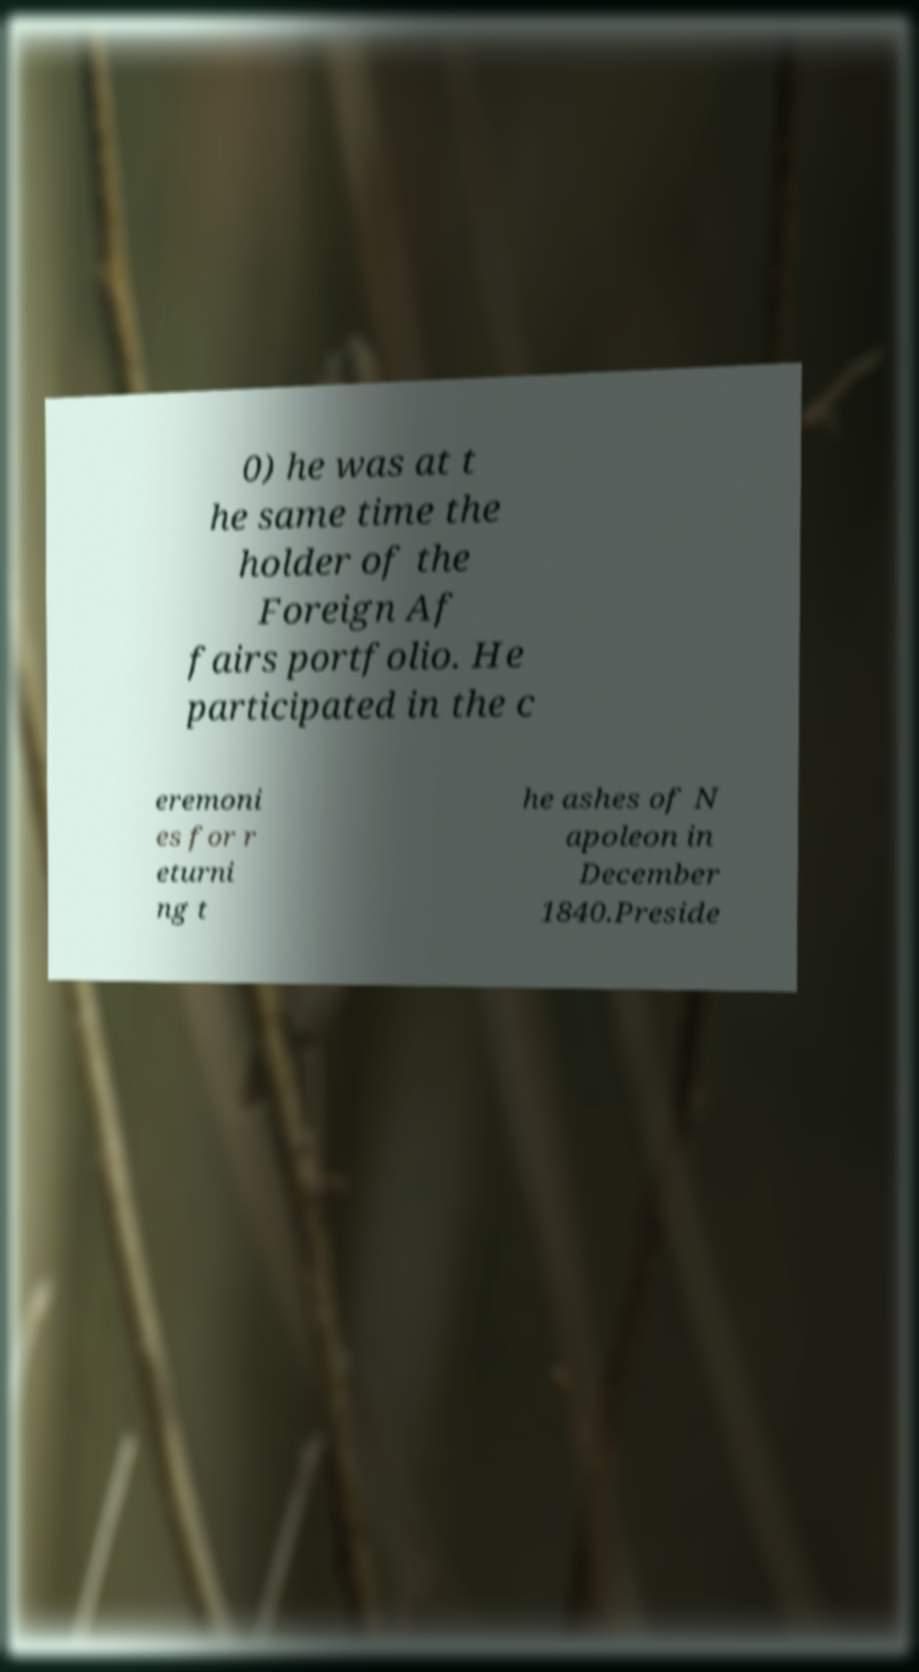Can you accurately transcribe the text from the provided image for me? 0) he was at t he same time the holder of the Foreign Af fairs portfolio. He participated in the c eremoni es for r eturni ng t he ashes of N apoleon in December 1840.Preside 